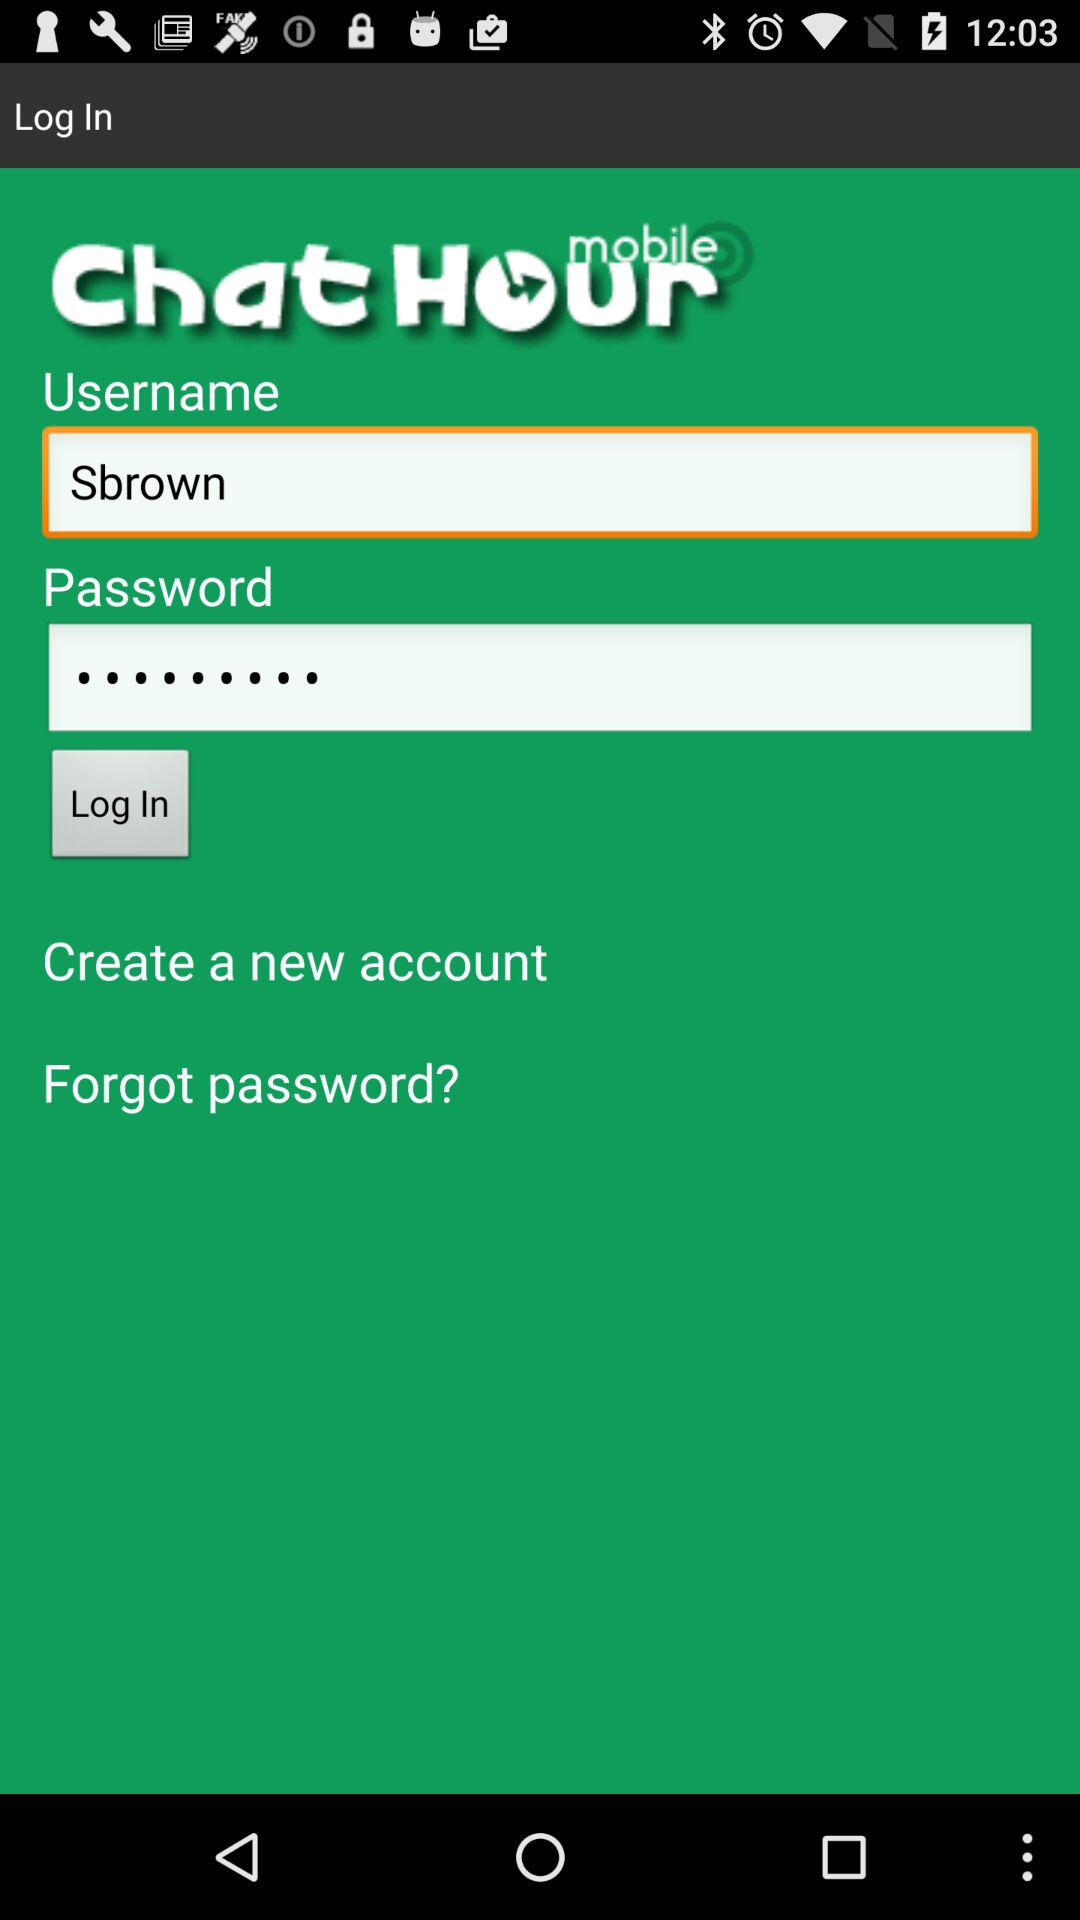What is the username? The username is "Sbrown". 